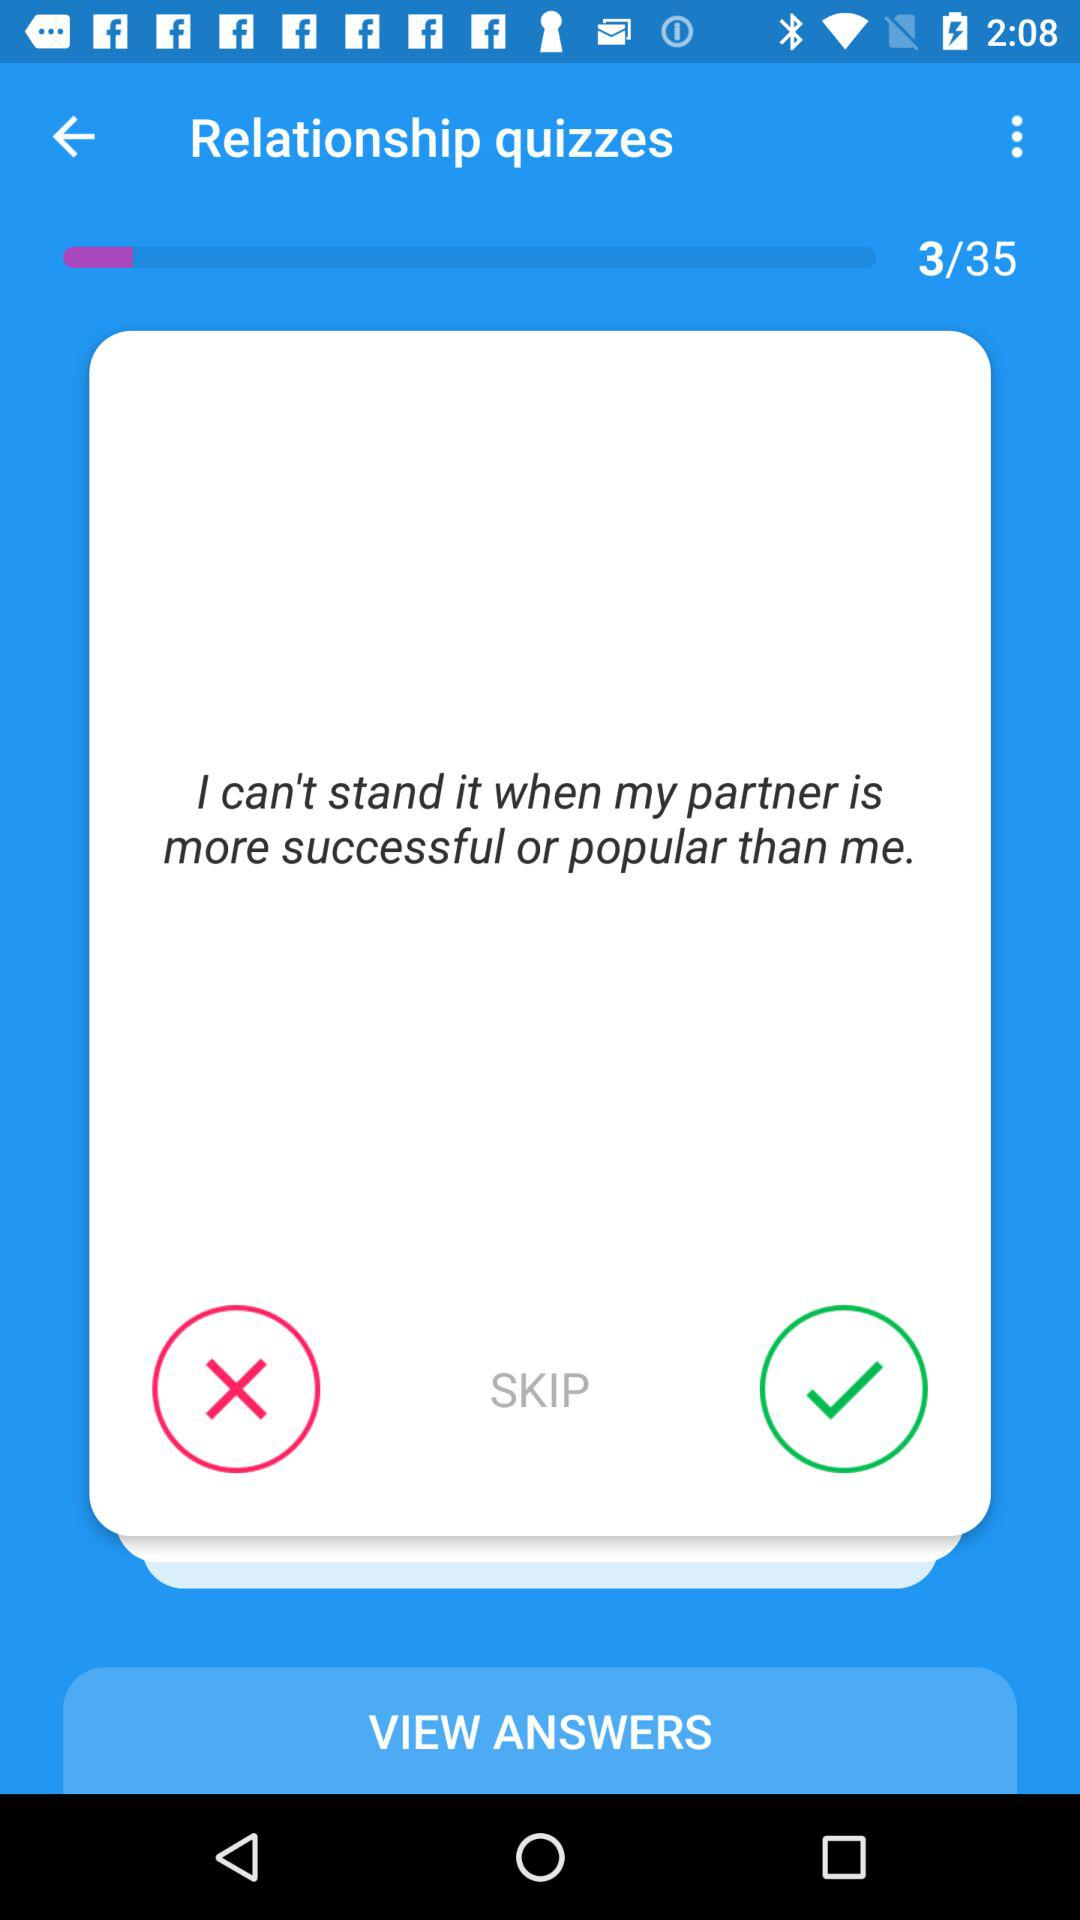Which is the current page number? The current page number is 3. 